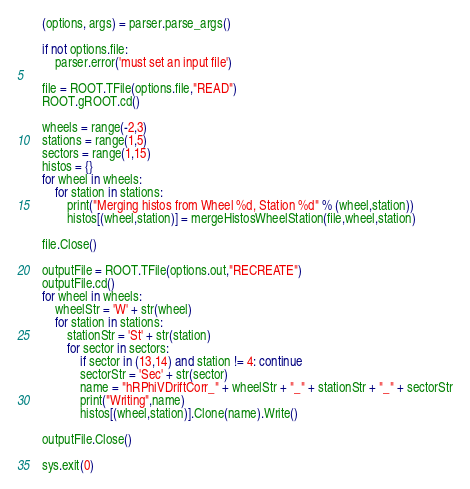<code> <loc_0><loc_0><loc_500><loc_500><_Python_>    (options, args) = parser.parse_args()

    if not options.file:
        parser.error('must set an input file')
    
    file = ROOT.TFile(options.file,"READ")
    ROOT.gROOT.cd()
 
    wheels = range(-2,3)
    stations = range(1,5)
    sectors = range(1,15)
    histos = {}
    for wheel in wheels:
        for station in stations:
            print("Merging histos from Wheel %d, Station %d" % (wheel,station))
            histos[(wheel,station)] = mergeHistosWheelStation(file,wheel,station) 
            
    file.Close()
  
    outputFile = ROOT.TFile(options.out,"RECREATE")
    outputFile.cd()
    for wheel in wheels:
        wheelStr = 'W' + str(wheel)
        for station in stations:
            stationStr = 'St' + str(station)
            for sector in sectors:
                if sector in (13,14) and station != 4: continue
                sectorStr = 'Sec' + str(sector)
                name = "hRPhiVDriftCorr_" + wheelStr + "_" + stationStr + "_" + sectorStr
                print("Writing",name) 
                histos[(wheel,station)].Clone(name).Write()
 
    outputFile.Close()

    sys.exit(0)
</code> 